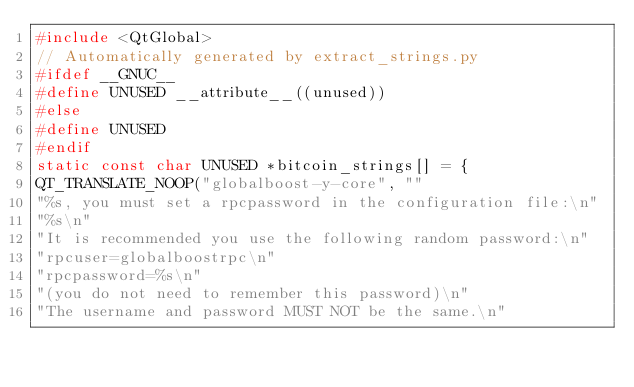Convert code to text. <code><loc_0><loc_0><loc_500><loc_500><_C++_>#include <QtGlobal>
// Automatically generated by extract_strings.py
#ifdef __GNUC__
#define UNUSED __attribute__((unused))
#else
#define UNUSED
#endif
static const char UNUSED *bitcoin_strings[] = {
QT_TRANSLATE_NOOP("globalboost-y-core", ""
"%s, you must set a rpcpassword in the configuration file:\n"
"%s\n"
"It is recommended you use the following random password:\n"
"rpcuser=globalboostrpc\n"
"rpcpassword=%s\n"
"(you do not need to remember this password)\n"
"The username and password MUST NOT be the same.\n"</code> 